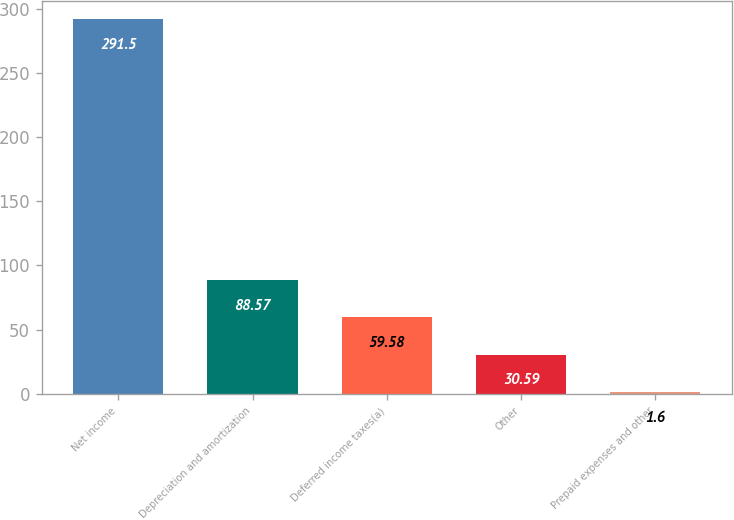Convert chart. <chart><loc_0><loc_0><loc_500><loc_500><bar_chart><fcel>Net income<fcel>Depreciation and amortization<fcel>Deferred income taxes(a)<fcel>Other<fcel>Prepaid expenses and other<nl><fcel>291.5<fcel>88.57<fcel>59.58<fcel>30.59<fcel>1.6<nl></chart> 